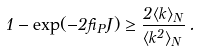<formula> <loc_0><loc_0><loc_500><loc_500>1 - \exp ( - 2 \beta _ { P } J ) \geq \frac { 2 \langle k \rangle _ { N } } { \langle k ^ { 2 } \rangle _ { N } } \, .</formula> 